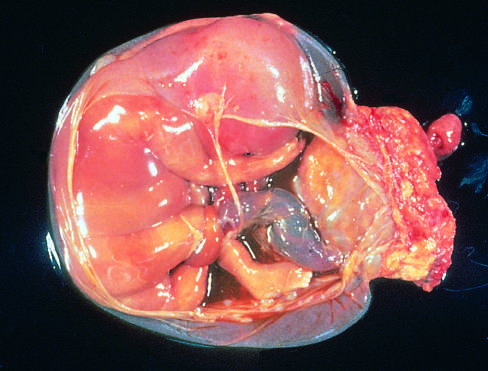where is the placenta, in the specimen shown?
Answer the question using a single word or phrase. At the right 